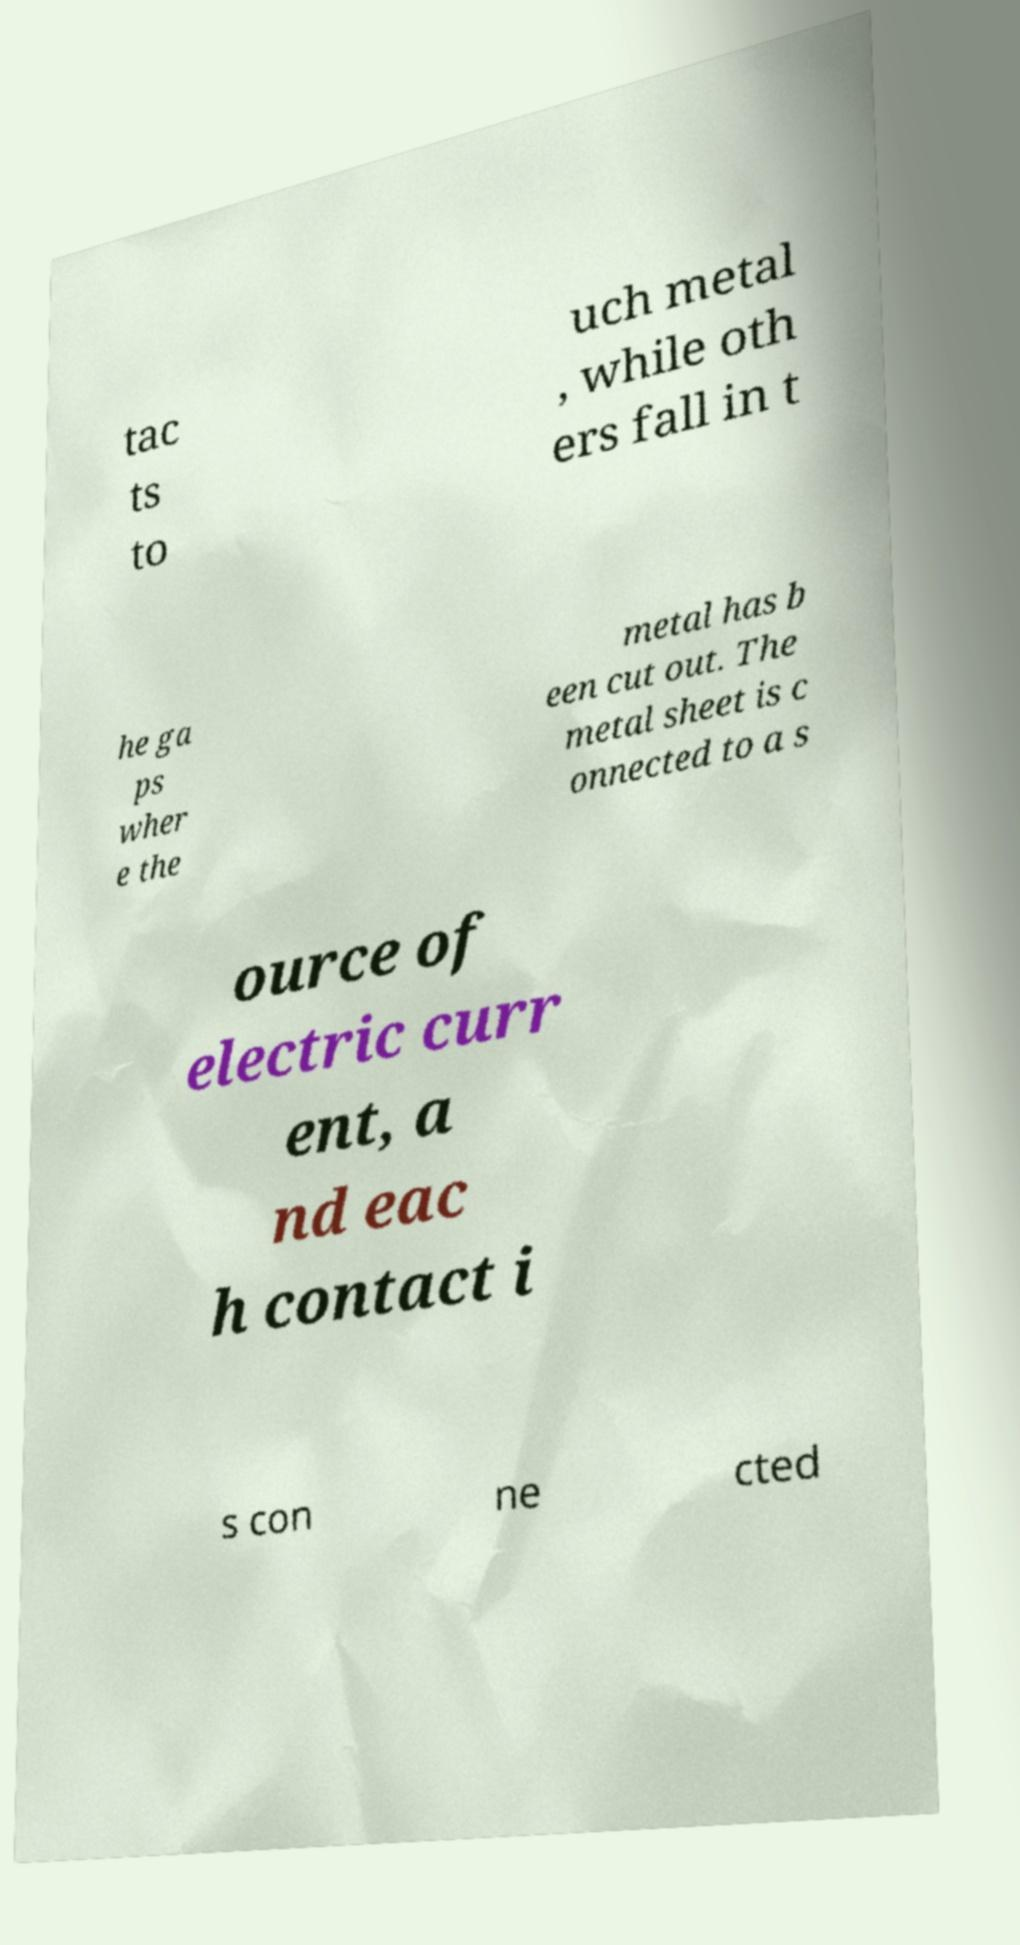For documentation purposes, I need the text within this image transcribed. Could you provide that? tac ts to uch metal , while oth ers fall in t he ga ps wher e the metal has b een cut out. The metal sheet is c onnected to a s ource of electric curr ent, a nd eac h contact i s con ne cted 